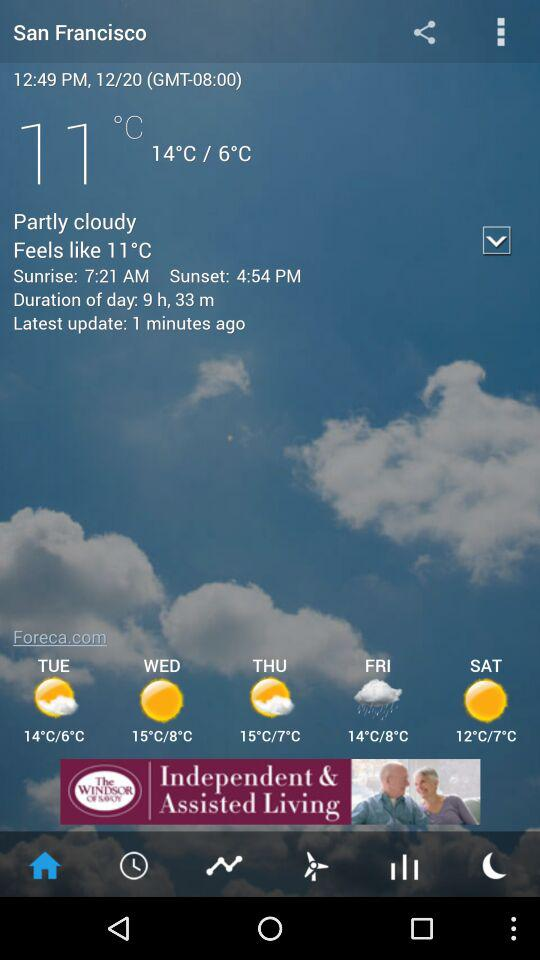How does the daytime length change throughout the year in this region? In San Francisco, the daytime length varies significantly throughout the year due to its mid-latitude location. The longest day is during the summer solstice in June, with sunlight lasting up to around 14 hours and 40 minutes, while the shortest day is during the winter solstice in December, with only about 9 hours and 30 minutes of daylight. 